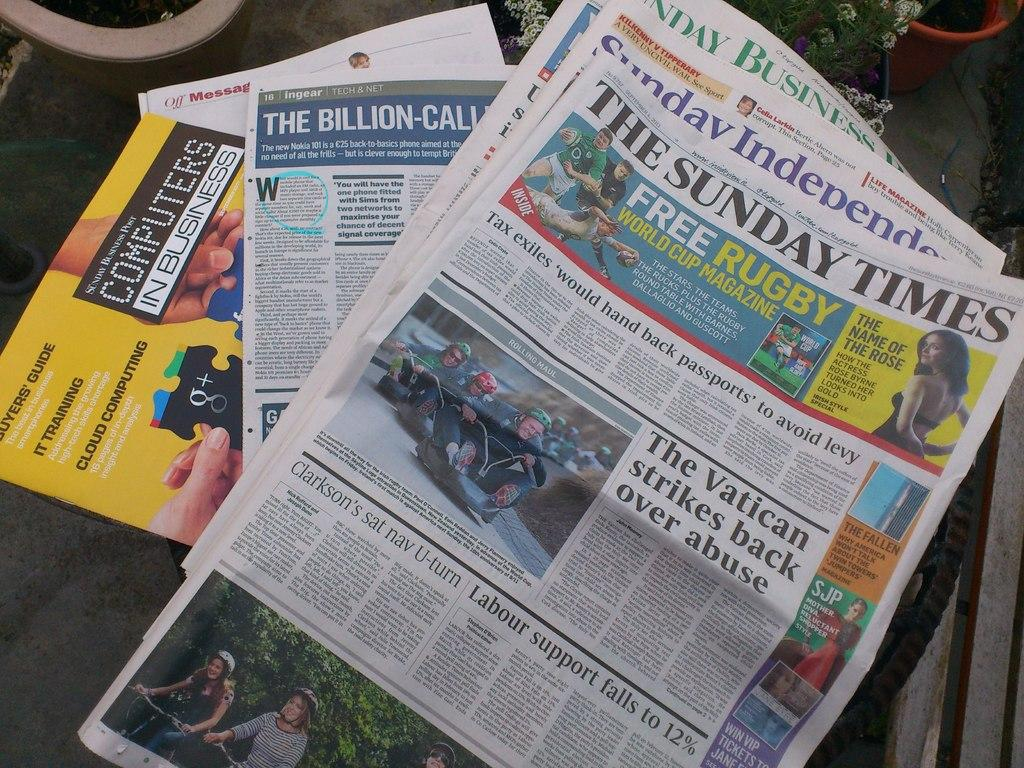Provide a one-sentence caption for the provided image. The Vatican once again makes the top news headline. 